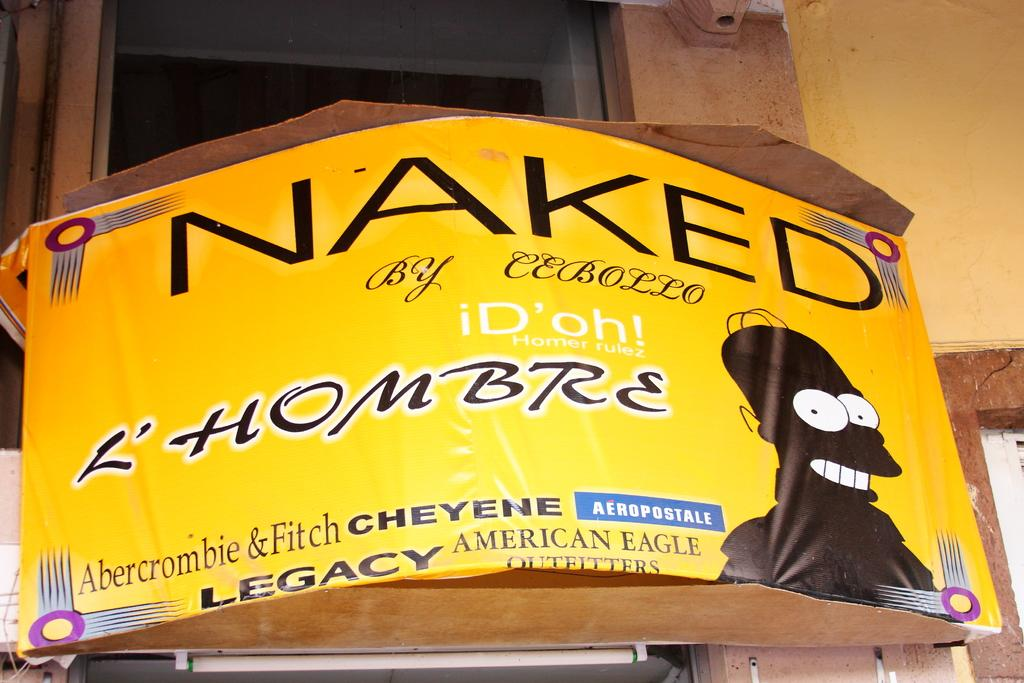What is the main object in the center of the image? There is a barrel in the center of the image. What is written on the barrel? There is text written on the barrel. What can be seen at the top of the image? There is a window on the top of the image. What is located on the right side of the image? There is a wall on the right side of the image. How many friends are sitting on the cloud in the image? There is no cloud or friends present in the image. What type of apparatus is used to interact with the wall in the image? There is no apparatus visible in the image; the wall is simply a part of the background. 